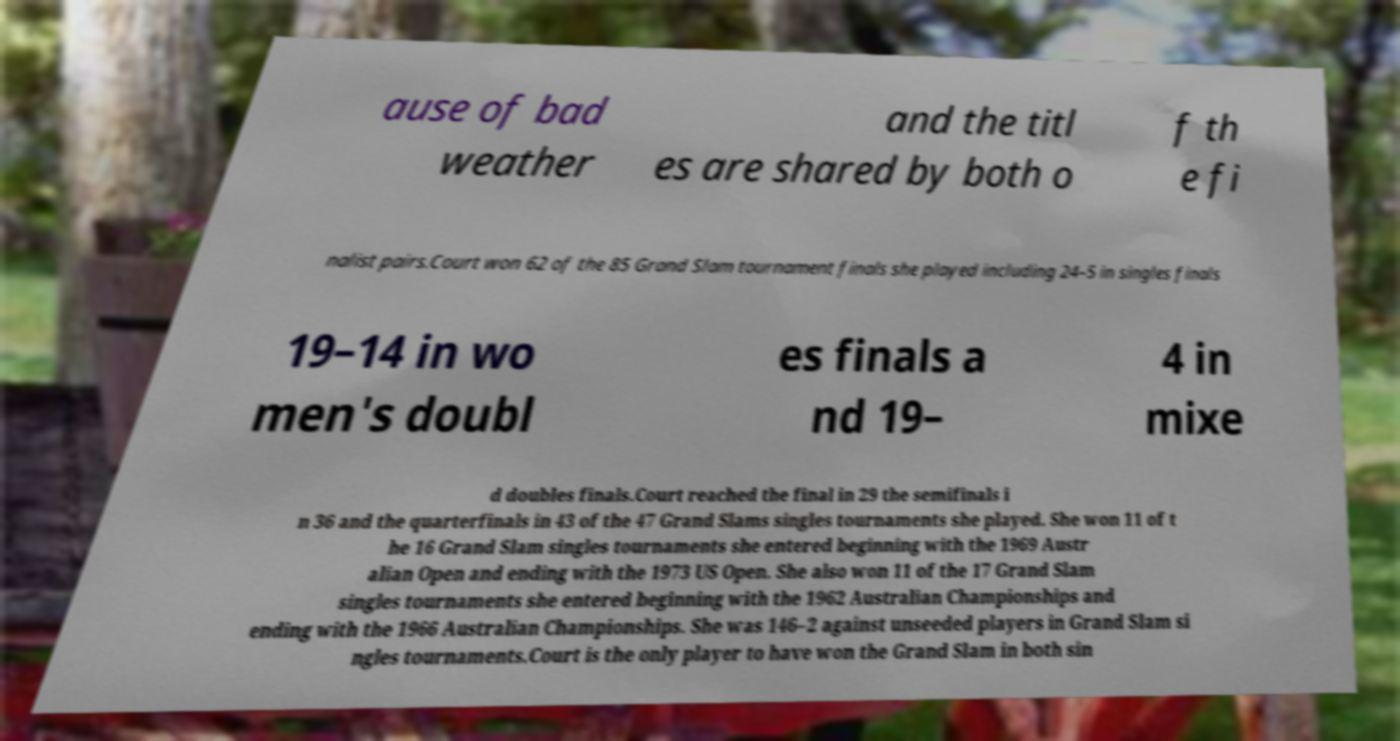Please identify and transcribe the text found in this image. ause of bad weather and the titl es are shared by both o f th e fi nalist pairs.Court won 62 of the 85 Grand Slam tournament finals she played including 24–5 in singles finals 19–14 in wo men's doubl es finals a nd 19– 4 in mixe d doubles finals.Court reached the final in 29 the semifinals i n 36 and the quarterfinals in 43 of the 47 Grand Slams singles tournaments she played. She won 11 of t he 16 Grand Slam singles tournaments she entered beginning with the 1969 Austr alian Open and ending with the 1973 US Open. She also won 11 of the 17 Grand Slam singles tournaments she entered beginning with the 1962 Australian Championships and ending with the 1966 Australian Championships. She was 146–2 against unseeded players in Grand Slam si ngles tournaments.Court is the only player to have won the Grand Slam in both sin 